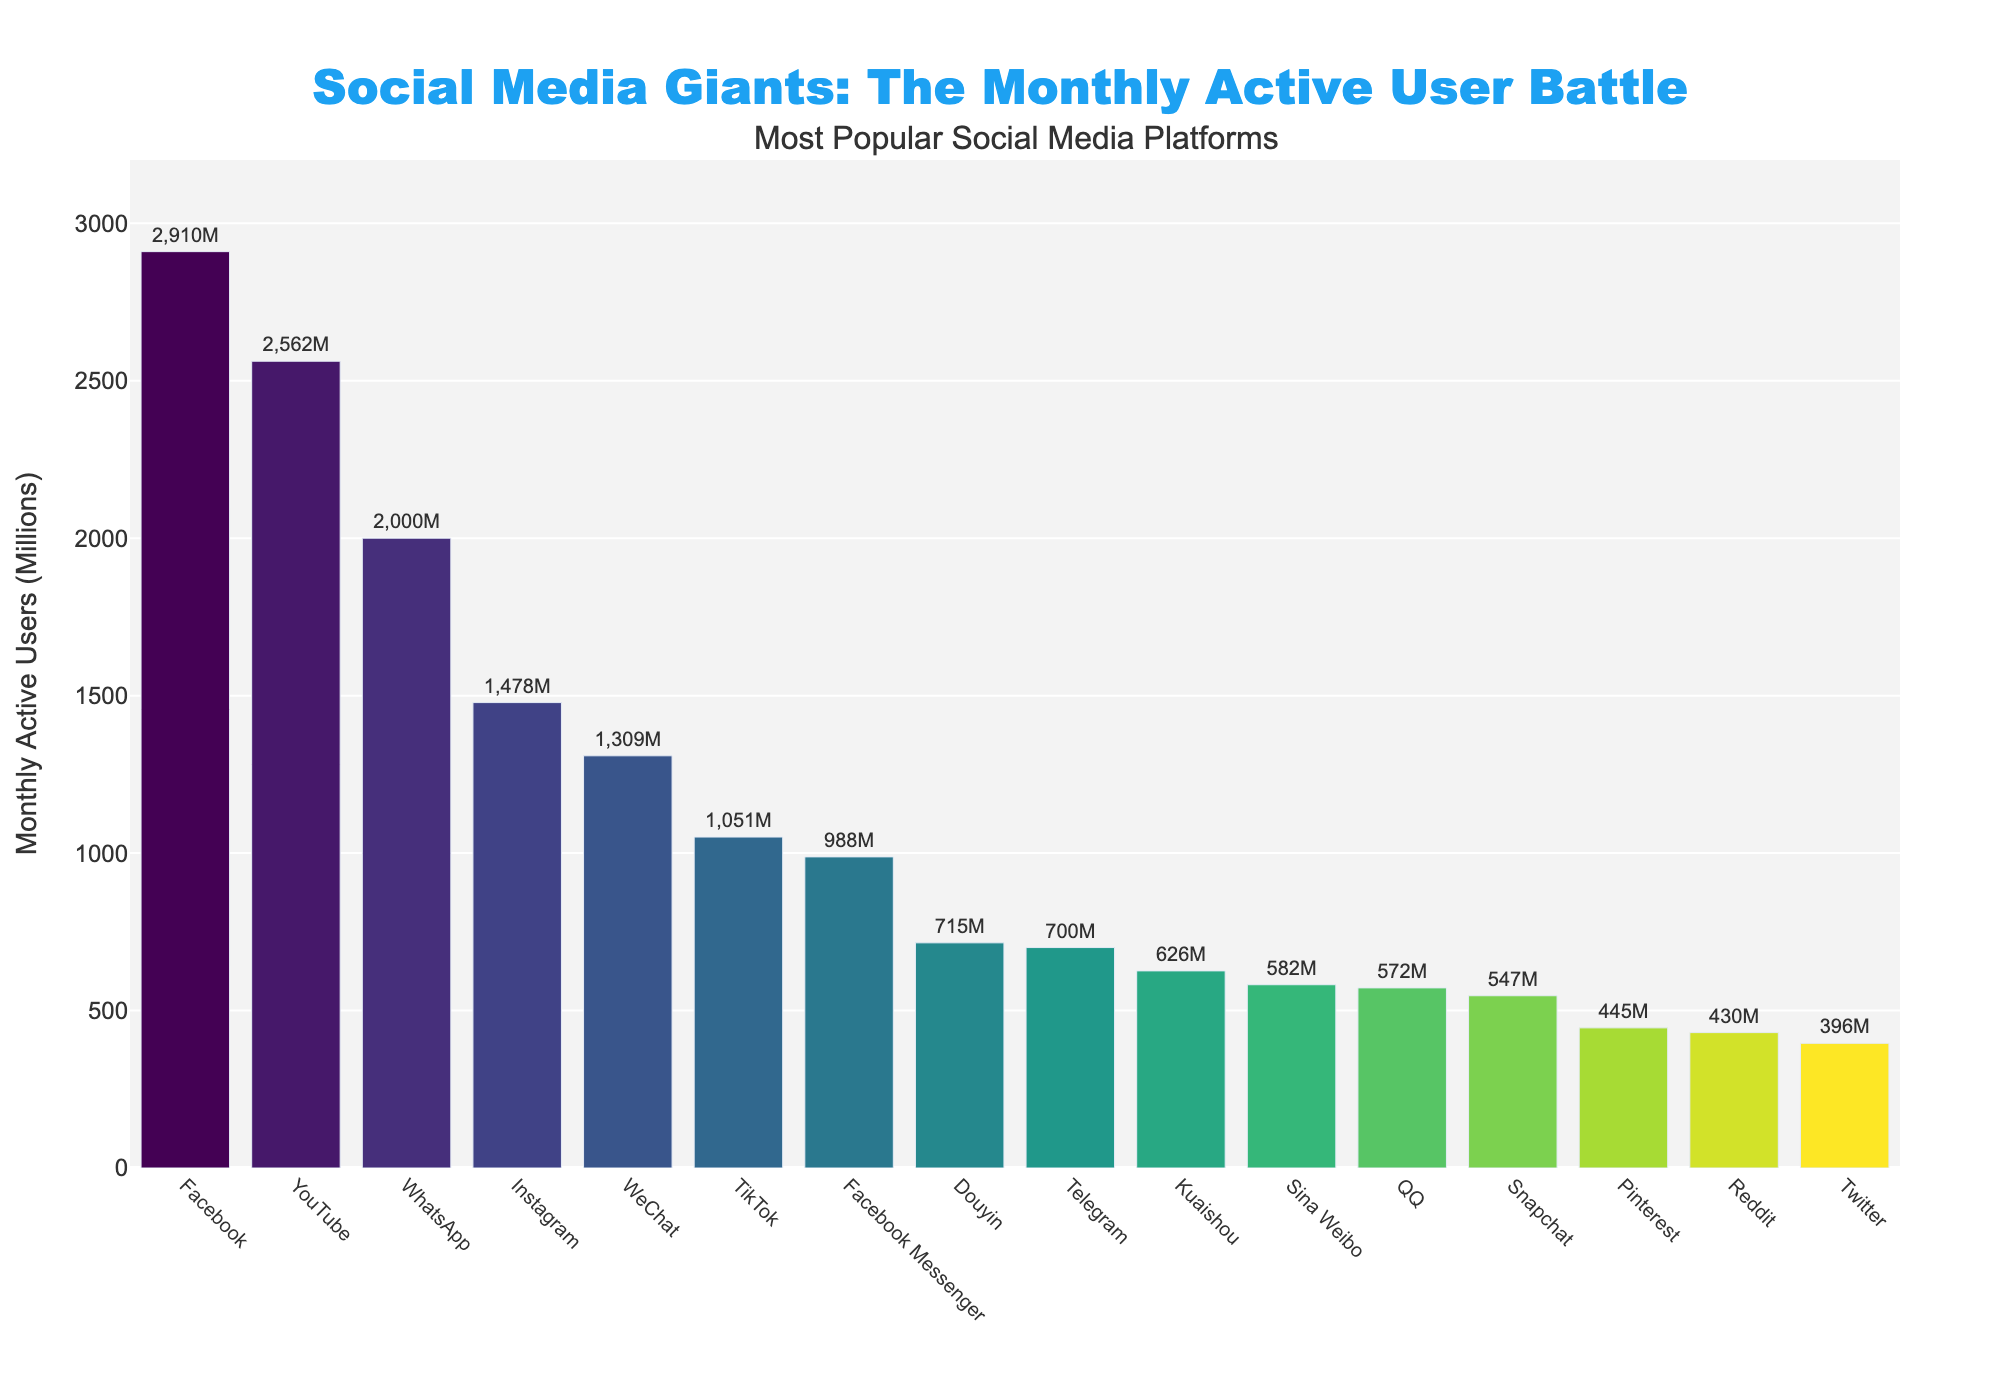What is the platform with the highest number of monthly active users? Facebook has the highest bar, indicating it has the most monthly active users at 2.91 billion.
Answer: Facebook How many platforms have more than 1 billion monthly active users? The platforms with more than 1 billion monthly active users are Facebook, YouTube, WhatsApp, Instagram, and WeChat, making a total of 5 platforms.
Answer: 5 Which platform has more users, TikTok or Instagram? By comparing the heights of the bars, Instagram has more users with 1.478 billion compared to TikTok's 1.051 billion.
Answer: Instagram What is the sum of monthly active users for Facebook and WhatsApp? Facebook has 2.91 billion users and WhatsApp has 2 billion users. Adding these together gives 2.91B + 2.0B = 4.91 billion users.
Answer: 4.91 billion Among Facebook Messenger, Douyin, and QQ, which platform has the fewest users, and how many are they? Douyin has the fewest users among the three, with 715 million monthly active users.
Answer: Douyin, 715 million What is the percentage difference in monthly active users between YouTube and Twitter? YouTube has 2.562 billion users, and Twitter has 396 million users. The difference is 2.562B - 396M = 2.166B. The percentage difference is (2.166B / 2.562B) * 100 ≈ 84.57%.
Answer: 84.57% What is the median value of monthly active users for all the platforms listed? The sorted list of user counts is: 396, 430, 445, 547, 572, 582, 626, 700, 715, 988, 1051, 1309, 1478, 2000, 2562, 2910. With 16 values, the median is the average of the 8th and 9th values: (700 + 715) / 2 = 707.5 million.
Answer: 707.5 million Which two platforms combined have fewer users than Facebook? Adding users of platforms with lower numbers such as Reddit (430M) and Snapchat (547M) gives 430M + 547M = 977M, which is less than Facebook's 2.91 billion.
Answer: Reddit and Snapchat Are there more users on Sina Weibo or Snapchat? By comparing the heights of the bars, Snapchat has fewer users with 547 million compared to Sina Weibo's 582 million.
Answer: Sina Weibo What is the average number of monthly active users across all platforms? Adding all values gives a total of (2910 + 2562 + 2000 + 1478 + 1309 + 1051 + 988 + 715 + 572 + 582 + 626 + 547 + 700 + 445 + 396 + 430) million = 19,311 million. Dividing by 16 (number of platforms) gives an average of approximately 1.206 billion users.
Answer: 1.207 billion 